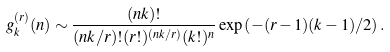Convert formula to latex. <formula><loc_0><loc_0><loc_500><loc_500>g _ { k } ^ { ( r ) } ( n ) \sim \frac { ( n k ) ! } { ( n k / r ) ! ( r ! ) ^ { ( n k / r ) } ( k ! ) ^ { n } } \exp \left ( - ( r - 1 ) ( k - 1 ) / 2 \right ) .</formula> 